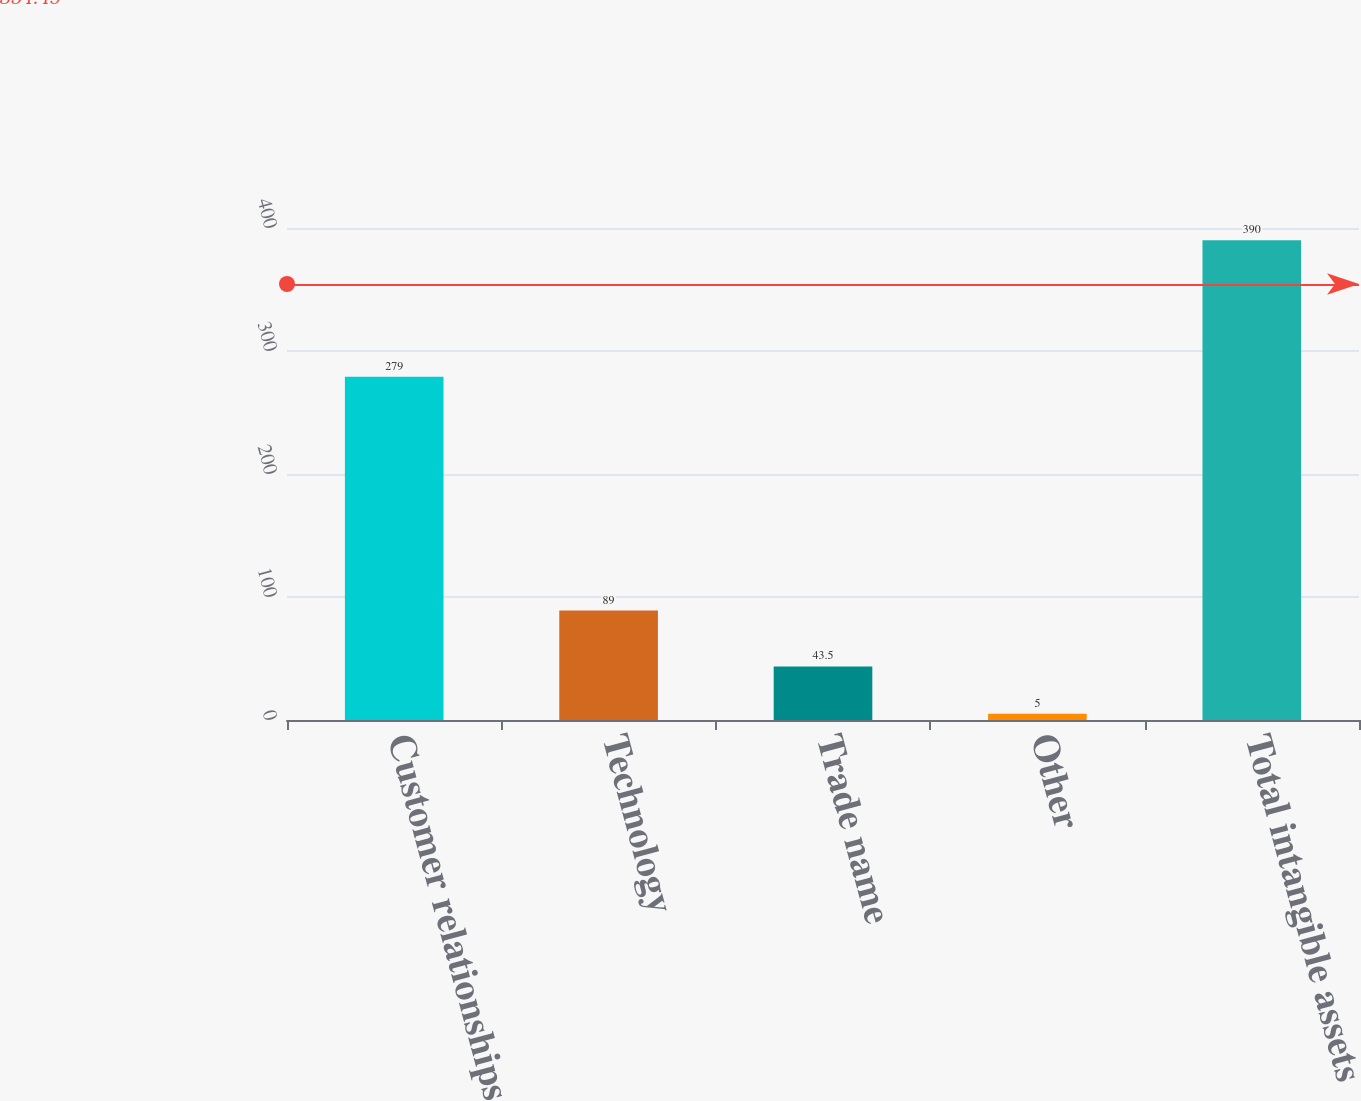Convert chart to OTSL. <chart><loc_0><loc_0><loc_500><loc_500><bar_chart><fcel>Customer relationships<fcel>Technology<fcel>Trade name<fcel>Other<fcel>Total intangible assets<nl><fcel>279<fcel>89<fcel>43.5<fcel>5<fcel>390<nl></chart> 